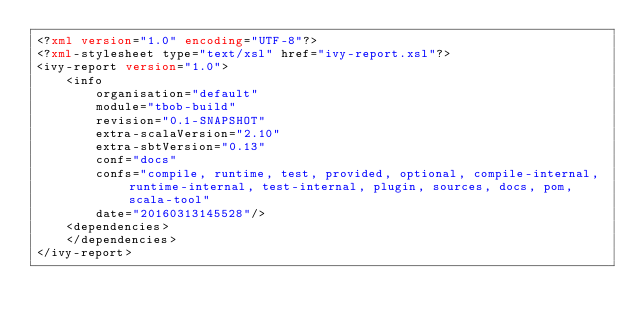<code> <loc_0><loc_0><loc_500><loc_500><_XML_><?xml version="1.0" encoding="UTF-8"?>
<?xml-stylesheet type="text/xsl" href="ivy-report.xsl"?>
<ivy-report version="1.0">
	<info
		organisation="default"
		module="tbob-build"
		revision="0.1-SNAPSHOT"
		extra-scalaVersion="2.10"
		extra-sbtVersion="0.13"
		conf="docs"
		confs="compile, runtime, test, provided, optional, compile-internal, runtime-internal, test-internal, plugin, sources, docs, pom, scala-tool"
		date="20160313145528"/>
	<dependencies>
	</dependencies>
</ivy-report>
</code> 